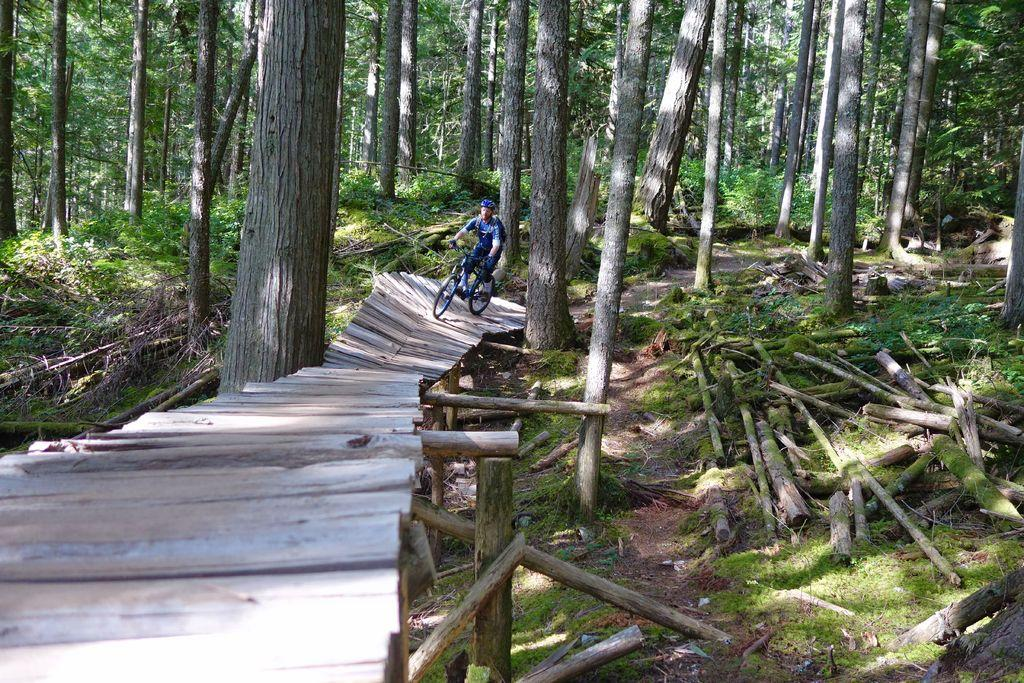What is the person in the image doing? The person is riding a bicycle in the image. Where is the person riding the bicycle? The person is on a wooden bridge in the image. What can be seen in the background of the image? There are trees in the background of the image. What type of vegetation is visible in the image? Green grass is visible in the image. What type of creature is polishing the bicycle in the image? There is no creature present in the image, and the bicycle is not being polished. 